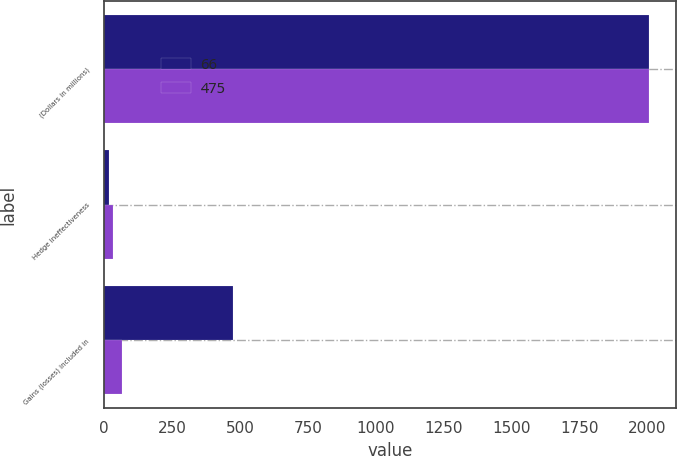<chart> <loc_0><loc_0><loc_500><loc_500><stacked_bar_chart><ecel><fcel>(Dollars in millions)<fcel>Hedge ineffectiveness<fcel>Gains (losses) included in<nl><fcel>66<fcel>2006<fcel>18<fcel>475<nl><fcel>475<fcel>2005<fcel>31<fcel>66<nl></chart> 